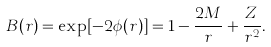Convert formula to latex. <formula><loc_0><loc_0><loc_500><loc_500>B ( r ) = \exp [ - 2 \phi ( r ) ] = 1 - { \frac { 2 M } { r } } + { \frac { Z } { r ^ { 2 } } } .</formula> 